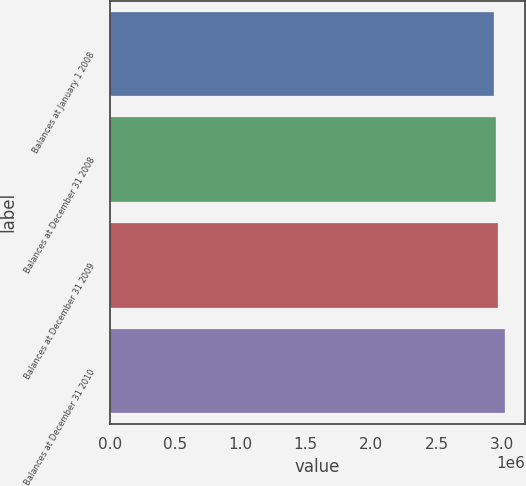<chart> <loc_0><loc_0><loc_500><loc_500><bar_chart><fcel>Balances at January 1 2008<fcel>Balances at December 31 2008<fcel>Balances at December 31 2009<fcel>Balances at December 31 2010<nl><fcel>2.94294e+06<fcel>2.95254e+06<fcel>2.9735e+06<fcel>3.02713e+06<nl></chart> 